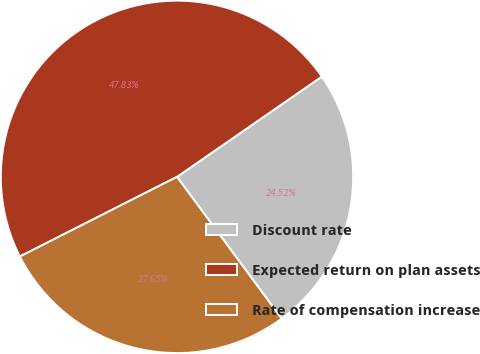Convert chart to OTSL. <chart><loc_0><loc_0><loc_500><loc_500><pie_chart><fcel>Discount rate<fcel>Expected return on plan assets<fcel>Rate of compensation increase<nl><fcel>24.52%<fcel>47.83%<fcel>27.65%<nl></chart> 